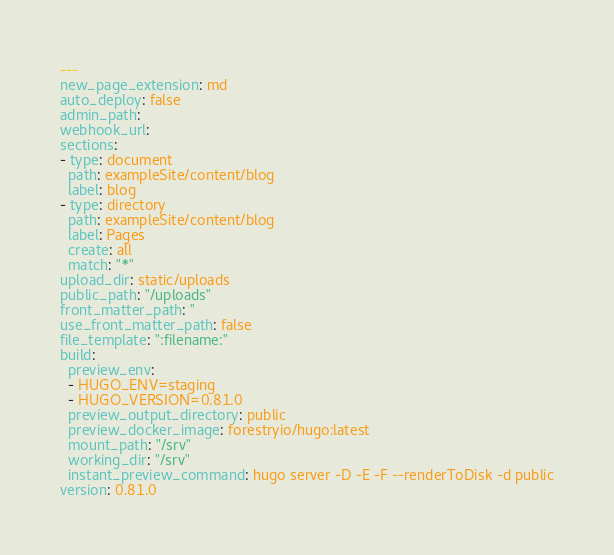Convert code to text. <code><loc_0><loc_0><loc_500><loc_500><_YAML_>---
new_page_extension: md
auto_deploy: false
admin_path: 
webhook_url: 
sections:
- type: document
  path: exampleSite/content/blog
  label: blog
- type: directory
  path: exampleSite/content/blog
  label: Pages
  create: all
  match: "*"
upload_dir: static/uploads
public_path: "/uploads"
front_matter_path: ''
use_front_matter_path: false
file_template: ":filename:"
build:
  preview_env:
  - HUGO_ENV=staging
  - HUGO_VERSION=0.81.0
  preview_output_directory: public
  preview_docker_image: forestryio/hugo:latest
  mount_path: "/srv"
  working_dir: "/srv"
  instant_preview_command: hugo server -D -E -F --renderToDisk -d public
version: 0.81.0
</code> 